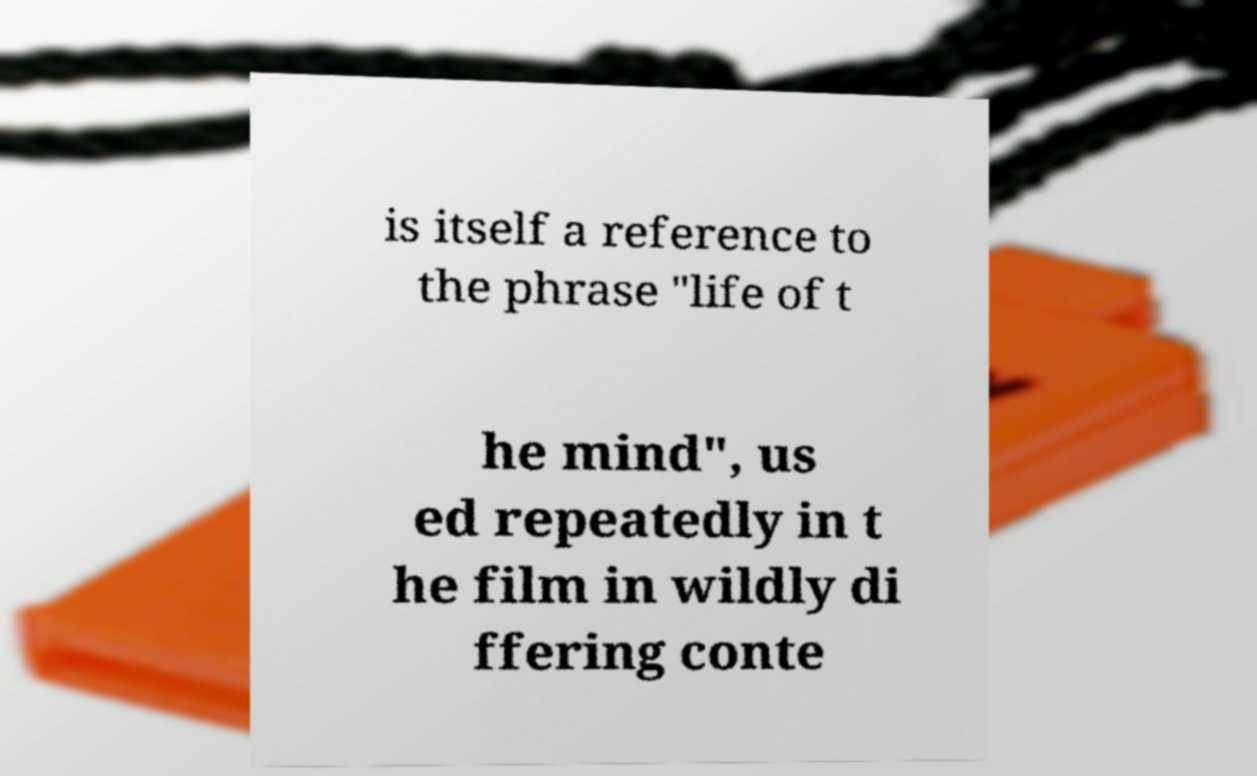Could you extract and type out the text from this image? is itself a reference to the phrase "life of t he mind", us ed repeatedly in t he film in wildly di ffering conte 